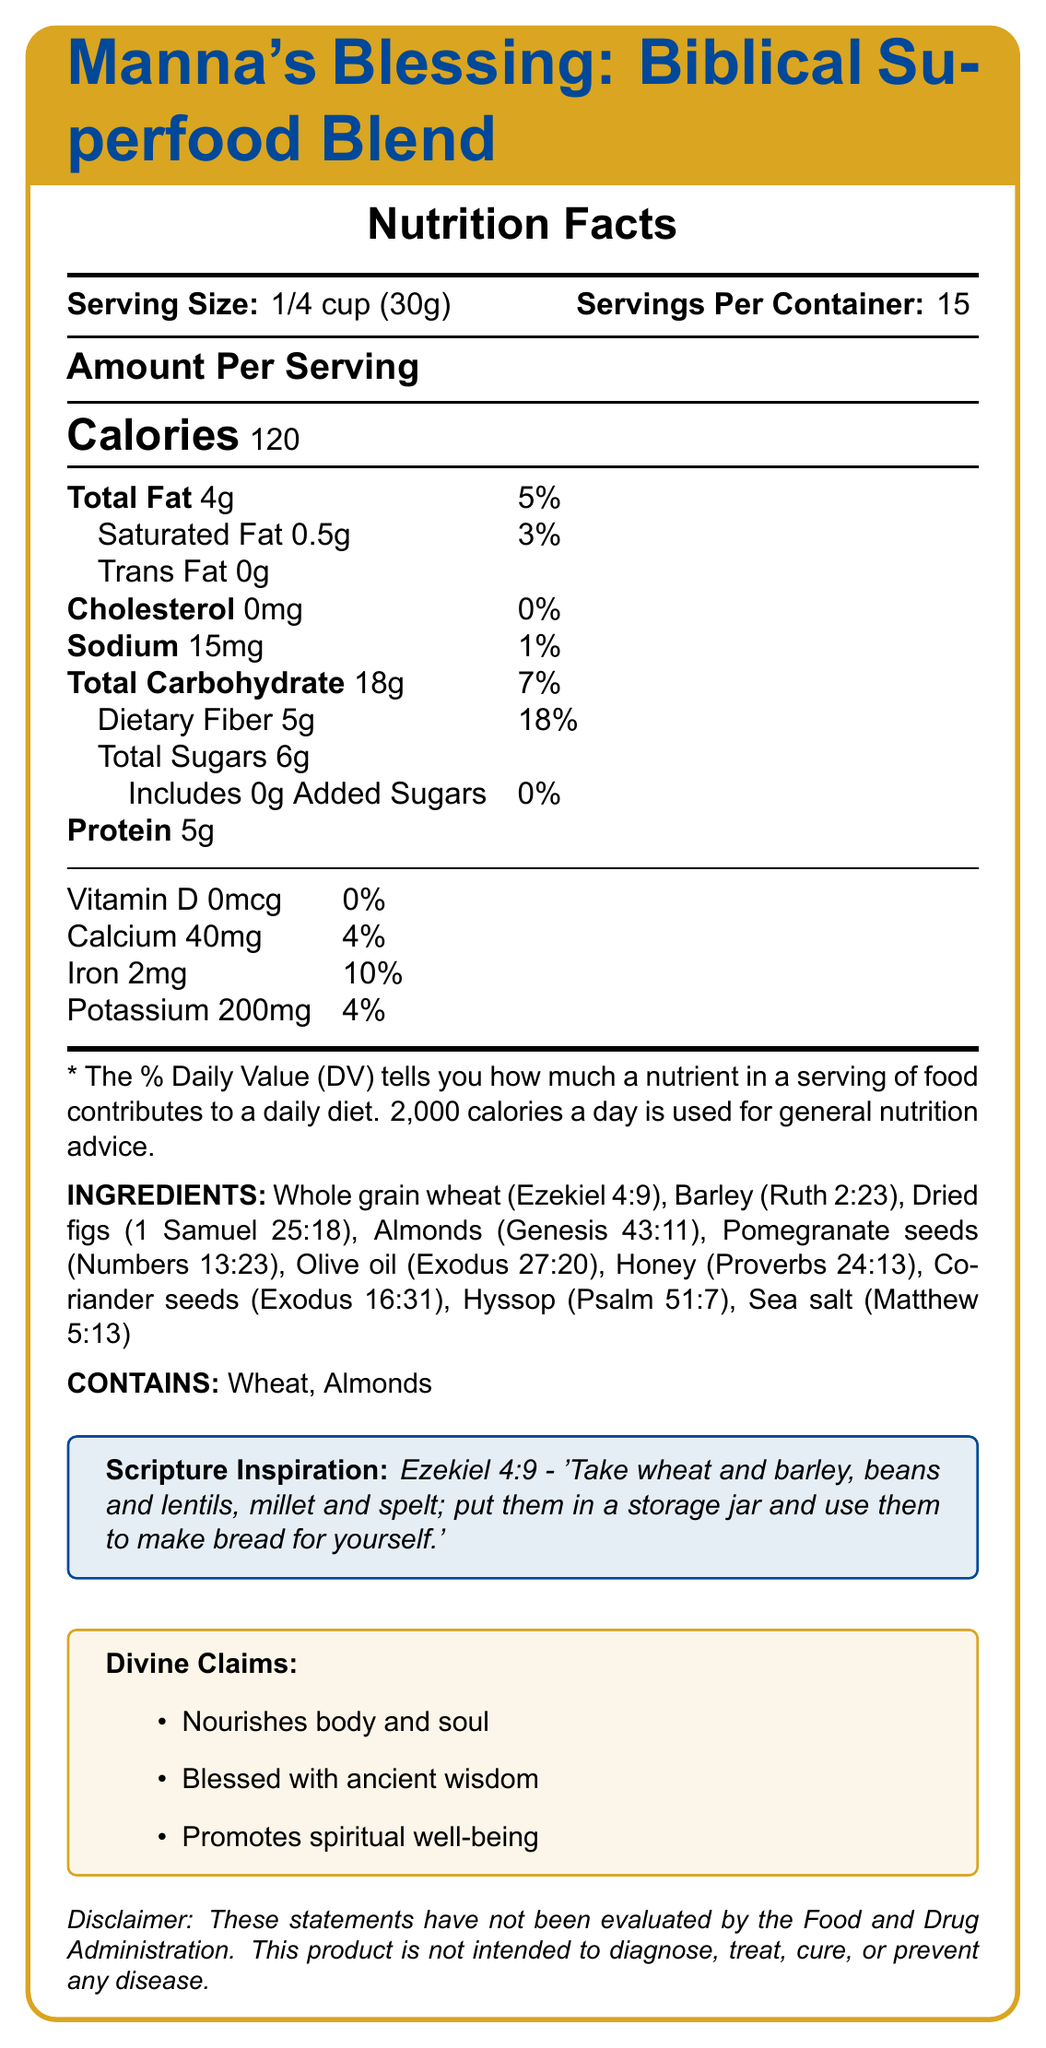What is the serving size of Manna's Blessing: Biblical Superfood Blend? The document specifies the serving size in the Nutrition Facts section.
Answer: 1/4 cup (30g) How many calories are in one serving? The number of calories per serving is prominently displayed in the Nutrition Facts section.
Answer: 120 calories What is the percentage of the daily value for total fat in one serving? The total fat daily value percentage is listed next to the amount of total fat.
Answer: 5% How much dietary fiber does one serving contain? The dietary fiber amount is listed under the Total Carbohydrate section.
Answer: 5g What is the scripture inspiration for this product? The Scripture Inspiration is explicitly stated in a highlighted box in the document.
Answer: Ezekiel 4:9 Which of these ingredients is mentioned with a Biblical reference to Genesis? A. Whole grain wheat B. Almonds C. Olive oil D. Barley Genesis 43:11 is referenced next to Almonds in the ingredients list.
Answer: B. Almonds What are the daily value percentages for iron and calcium? A. Iron 10%, Calcium 4% B. Iron 4%, Calcium 10% C. Iron 10%, Calcium 10% D. Iron 4%, Calcium 4% The daily values for iron and calcium are listed in the Vitamins and Minerals section.
Answer: A. Iron 10%, Calcium 4% Is there any vitamin D in one serving of the product? The document lists Vitamin D as 0mcg with a daily value of 0%.
Answer: No Does this product contain any trans fat? Trans fat is listed as 0g in the Nutrition Facts.
Answer: No Summarize the main idea of this document. The document provides a comprehensive overview of the nutritional content, ingredient sources, and spiritual inspiration for "Manna's Blessing: Biblical Superfood Blend," emphasizing its link to Biblical passages and ancient wisdom.
Answer: The document is a detailed Nutrition Facts Label for "Manna's Blessing: Biblical Superfood Blend," a product inspired by Biblical ingredients and verses. It includes nutritional information, ingredients list, allergen information, scripture inspiration, and divine claims about the product's benefits. How many servings are in one container of the product? The number of servings per container is listed in the Nutrition Facts section.
Answer: 15 How much sodium is in one serving of this product? The amount of sodium is listed in the Nutrition Facts section.
Answer: 15mg Can the divine claims stated be verified by the FDA? The disclaimer explicitly states that the claims have not been evaluated by the Food and Drug Administration.
Answer: No Which allergens are mentioned in the allergen information? The allergen information specifies that the product contains wheat and almonds.
Answer: Wheat, Almonds Given the nutritional details, would you say this product is high in fiber? With 5g of dietary fiber per serving (18% daily value), this product is considered high in fiber.
Answer: Yes What is the amount of total sugars in one serving? The amount of total sugars is listed in the Nutrition Facts section.
Answer: 6g What are the divine claims made about this product? The divine claims are listed in a highlighted box in the document.
Answer: Nourishes body and soul, Blessed with ancient wisdom, Promotes spiritual well-being Is the amount of added sugars in this product significant? The document specifies that the added sugars are 0g, which is 0% of the daily value.
Answer: No Where is the reference to Sea Salt found in the Bible according to the ingredients list? The ingredients list includes Sea Salt with a reference to Matthew 5:13.
Answer: Matthew 5:13 Does the product include any beans or lentils, as mentioned in Ezekiel 4:9? The ingredients list does not mention beans or lentils, only other components referenced in Ezekiel 4:9.
Answer: No 